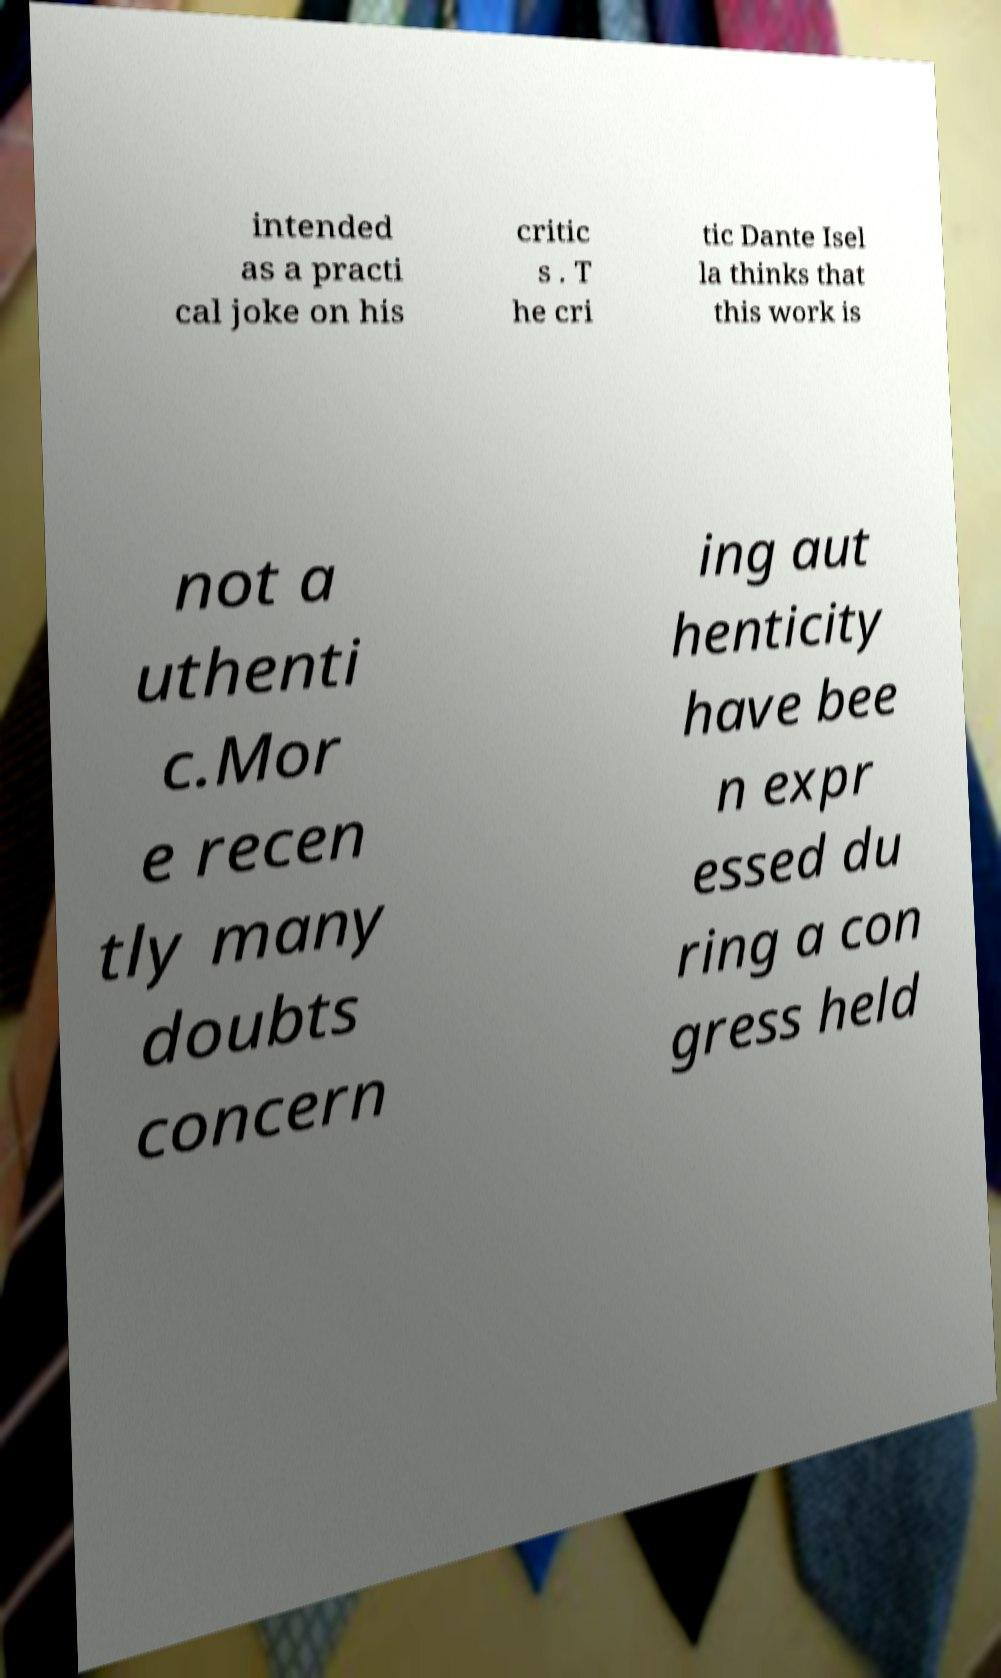Please identify and transcribe the text found in this image. intended as a practi cal joke on his critic s . T he cri tic Dante Isel la thinks that this work is not a uthenti c.Mor e recen tly many doubts concern ing aut henticity have bee n expr essed du ring a con gress held 